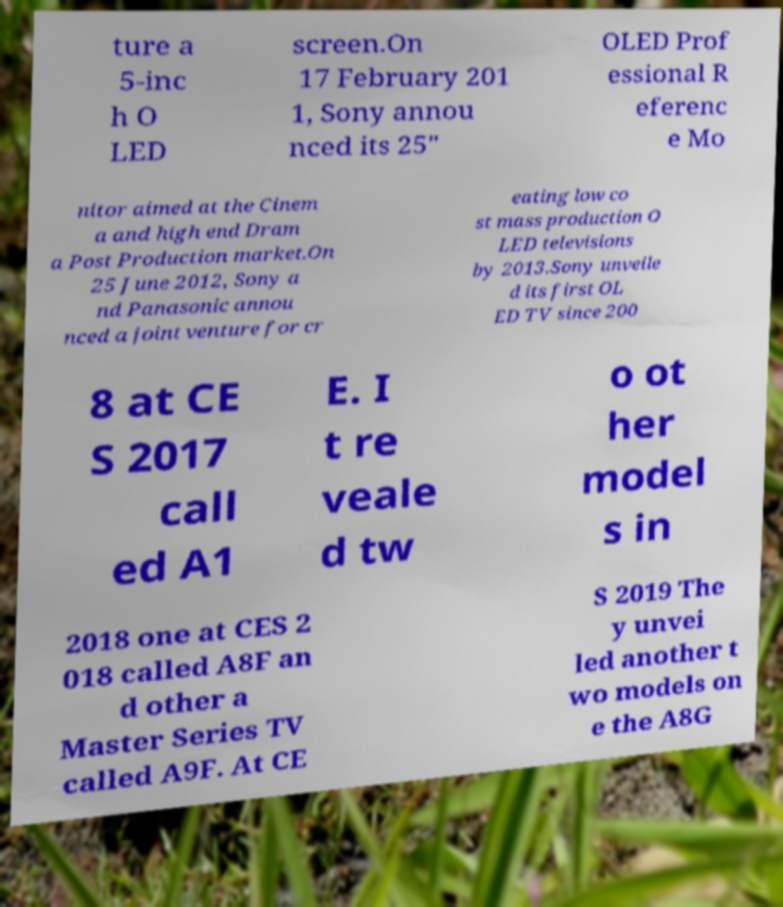Can you accurately transcribe the text from the provided image for me? ture a 5-inc h O LED screen.On 17 February 201 1, Sony annou nced its 25" OLED Prof essional R eferenc e Mo nitor aimed at the Cinem a and high end Dram a Post Production market.On 25 June 2012, Sony a nd Panasonic annou nced a joint venture for cr eating low co st mass production O LED televisions by 2013.Sony unveile d its first OL ED TV since 200 8 at CE S 2017 call ed A1 E. I t re veale d tw o ot her model s in 2018 one at CES 2 018 called A8F an d other a Master Series TV called A9F. At CE S 2019 The y unvei led another t wo models on e the A8G 